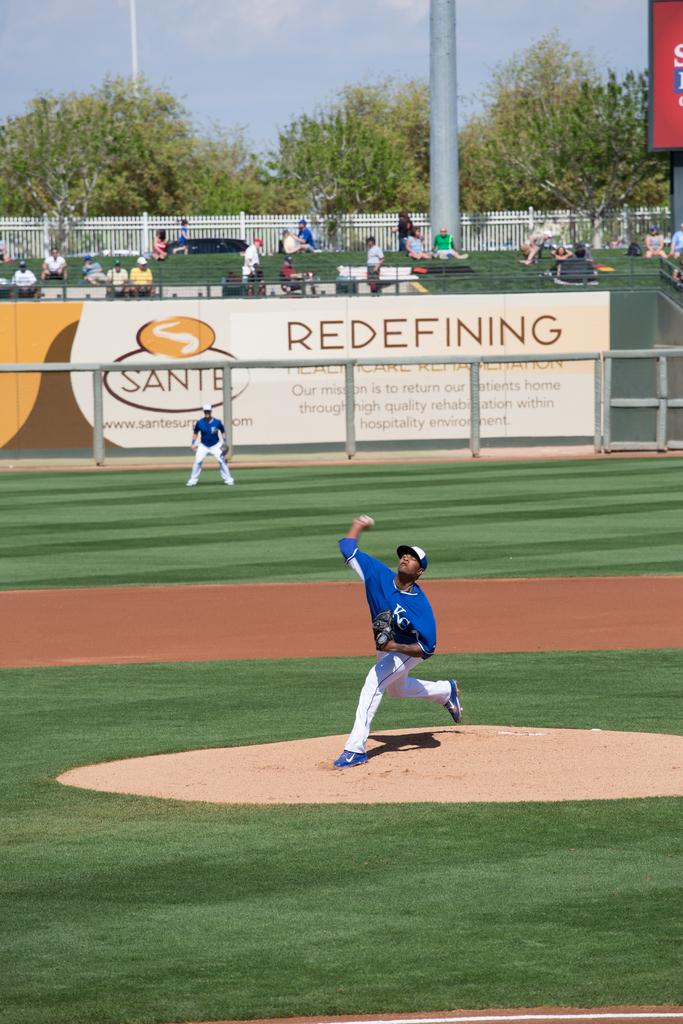What is the name of the advertiser?
Make the answer very short. Sante. What are the initials on the pitchers jersey?
Give a very brief answer. Kc. 